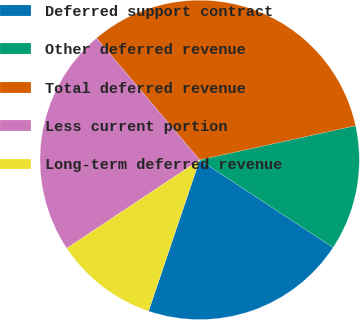Convert chart. <chart><loc_0><loc_0><loc_500><loc_500><pie_chart><fcel>Deferred support contract<fcel>Other deferred revenue<fcel>Total deferred revenue<fcel>Less current portion<fcel>Long-term deferred revenue<nl><fcel>20.93%<fcel>12.69%<fcel>32.74%<fcel>23.16%<fcel>10.47%<nl></chart> 